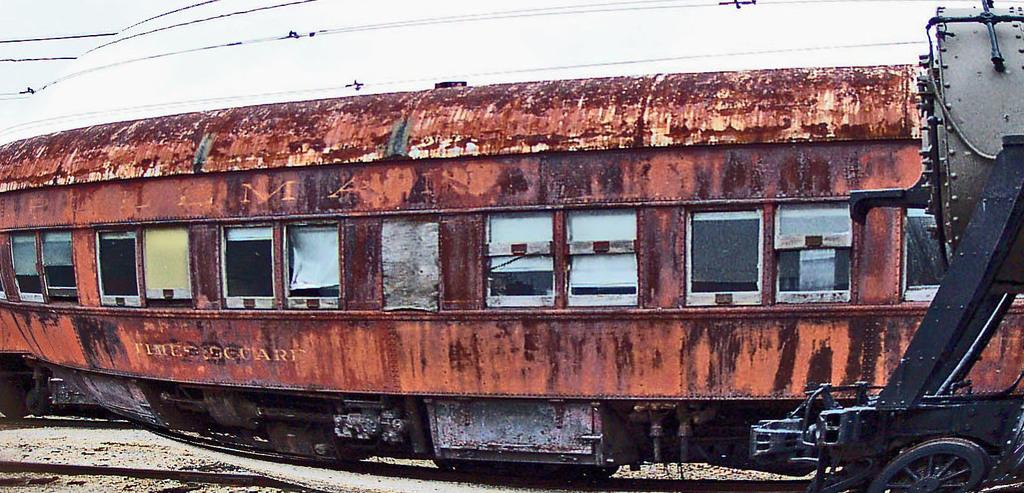What is the main subject of the image? The main subject of the image is a train. Where is the train located in the image? The train is on a railway track. What can be seen in the background of the image? There are wires and the sky visible in the background of the image. What type of engine is powering the table in the image? There is no table or engine present in the image; it features a train on a railway track. 